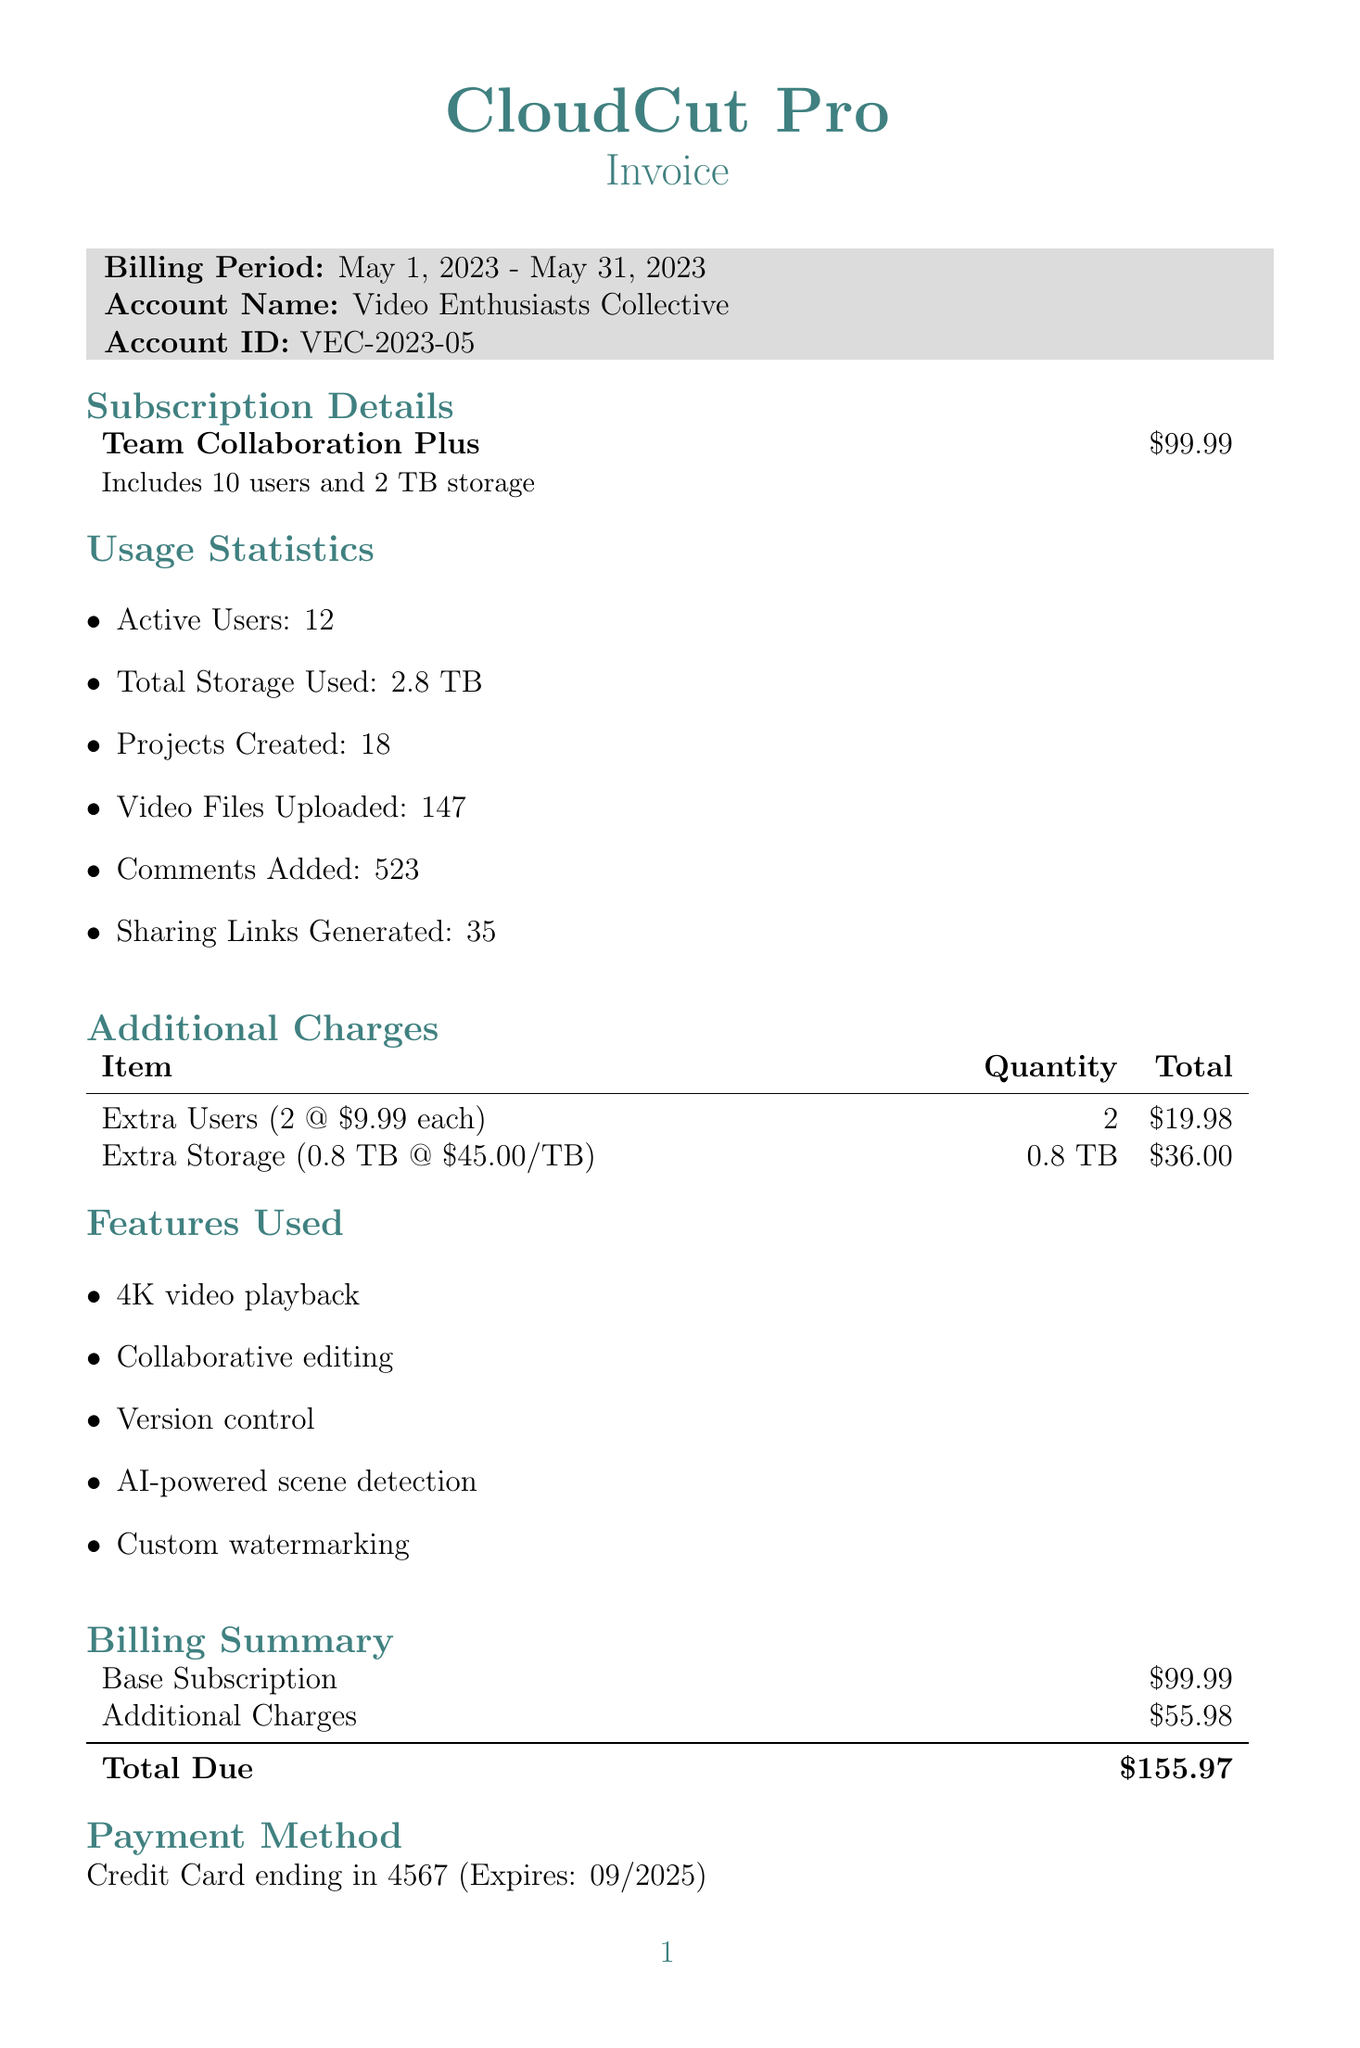What is the account name? The account name is provided in the invoice details section.
Answer: Video Enthusiasts Collective What is the billing period? The billing period is stated in the invoice details section of the document.
Answer: May 1, 2023 - May 31, 2023 How many active users are there? The number of active users is included in the usage statistics section of the document.
Answer: 12 What is the total due amount? The total due amount is found in the billing summary section of the invoice.
Answer: $155.97 How much extra storage was used? The invoice specifies the additional storage used in the additional charges section.
Answer: 0.8 TB How many video files were uploaded? The number of video files uploaded is provided in the usage statistics section.
Answer: 147 What payment method was used? The payment method is described in the payment method section of the document.
Answer: Credit Card What features were used? Features used are listed in the features used section of the document.
Answer: 4K video playback, Collaborative editing, Version control, AI-powered scene detection, Custom watermarking How many projects were created? The number of projects created is stated in the usage statistics section.
Answer: 18 What is the price per extra user? The price for each extra user is mentioned in the additional charges section.
Answer: $9.99 